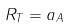Convert formula to latex. <formula><loc_0><loc_0><loc_500><loc_500>R _ { T } = a _ { A }</formula> 